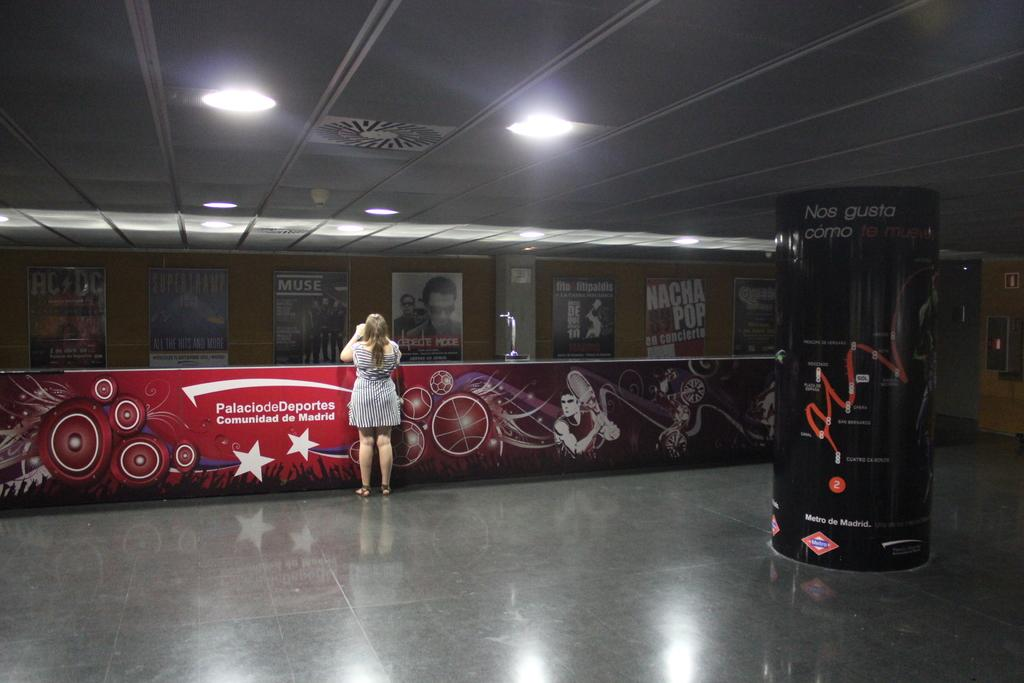What can be seen on the ground in the image? The floor is visible in the image. What is the woman near in the image? There is a desk near the woman in the image. How many lights are on the ceiling in the image? There are two lights on the ceiling in the image. What type of corn is being discussed by the woman in the image? There is no corn or discussion about corn present in the image. Is the woman's father visible in the image? There is no indication of the woman's father being present in the image. 